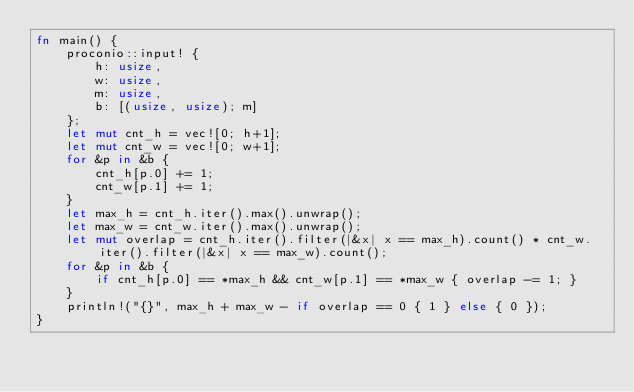Convert code to text. <code><loc_0><loc_0><loc_500><loc_500><_Rust_>fn main() {
    proconio::input! {
        h: usize,
        w: usize,
        m: usize,
        b: [(usize, usize); m]
    };
    let mut cnt_h = vec![0; h+1];
    let mut cnt_w = vec![0; w+1];
    for &p in &b {
        cnt_h[p.0] += 1;
        cnt_w[p.1] += 1;
    }
    let max_h = cnt_h.iter().max().unwrap();
    let max_w = cnt_w.iter().max().unwrap();
    let mut overlap = cnt_h.iter().filter(|&x| x == max_h).count() * cnt_w.iter().filter(|&x| x == max_w).count();
    for &p in &b {
        if cnt_h[p.0] == *max_h && cnt_w[p.1] == *max_w { overlap -= 1; }
    }
    println!("{}", max_h + max_w - if overlap == 0 { 1 } else { 0 });
}
</code> 